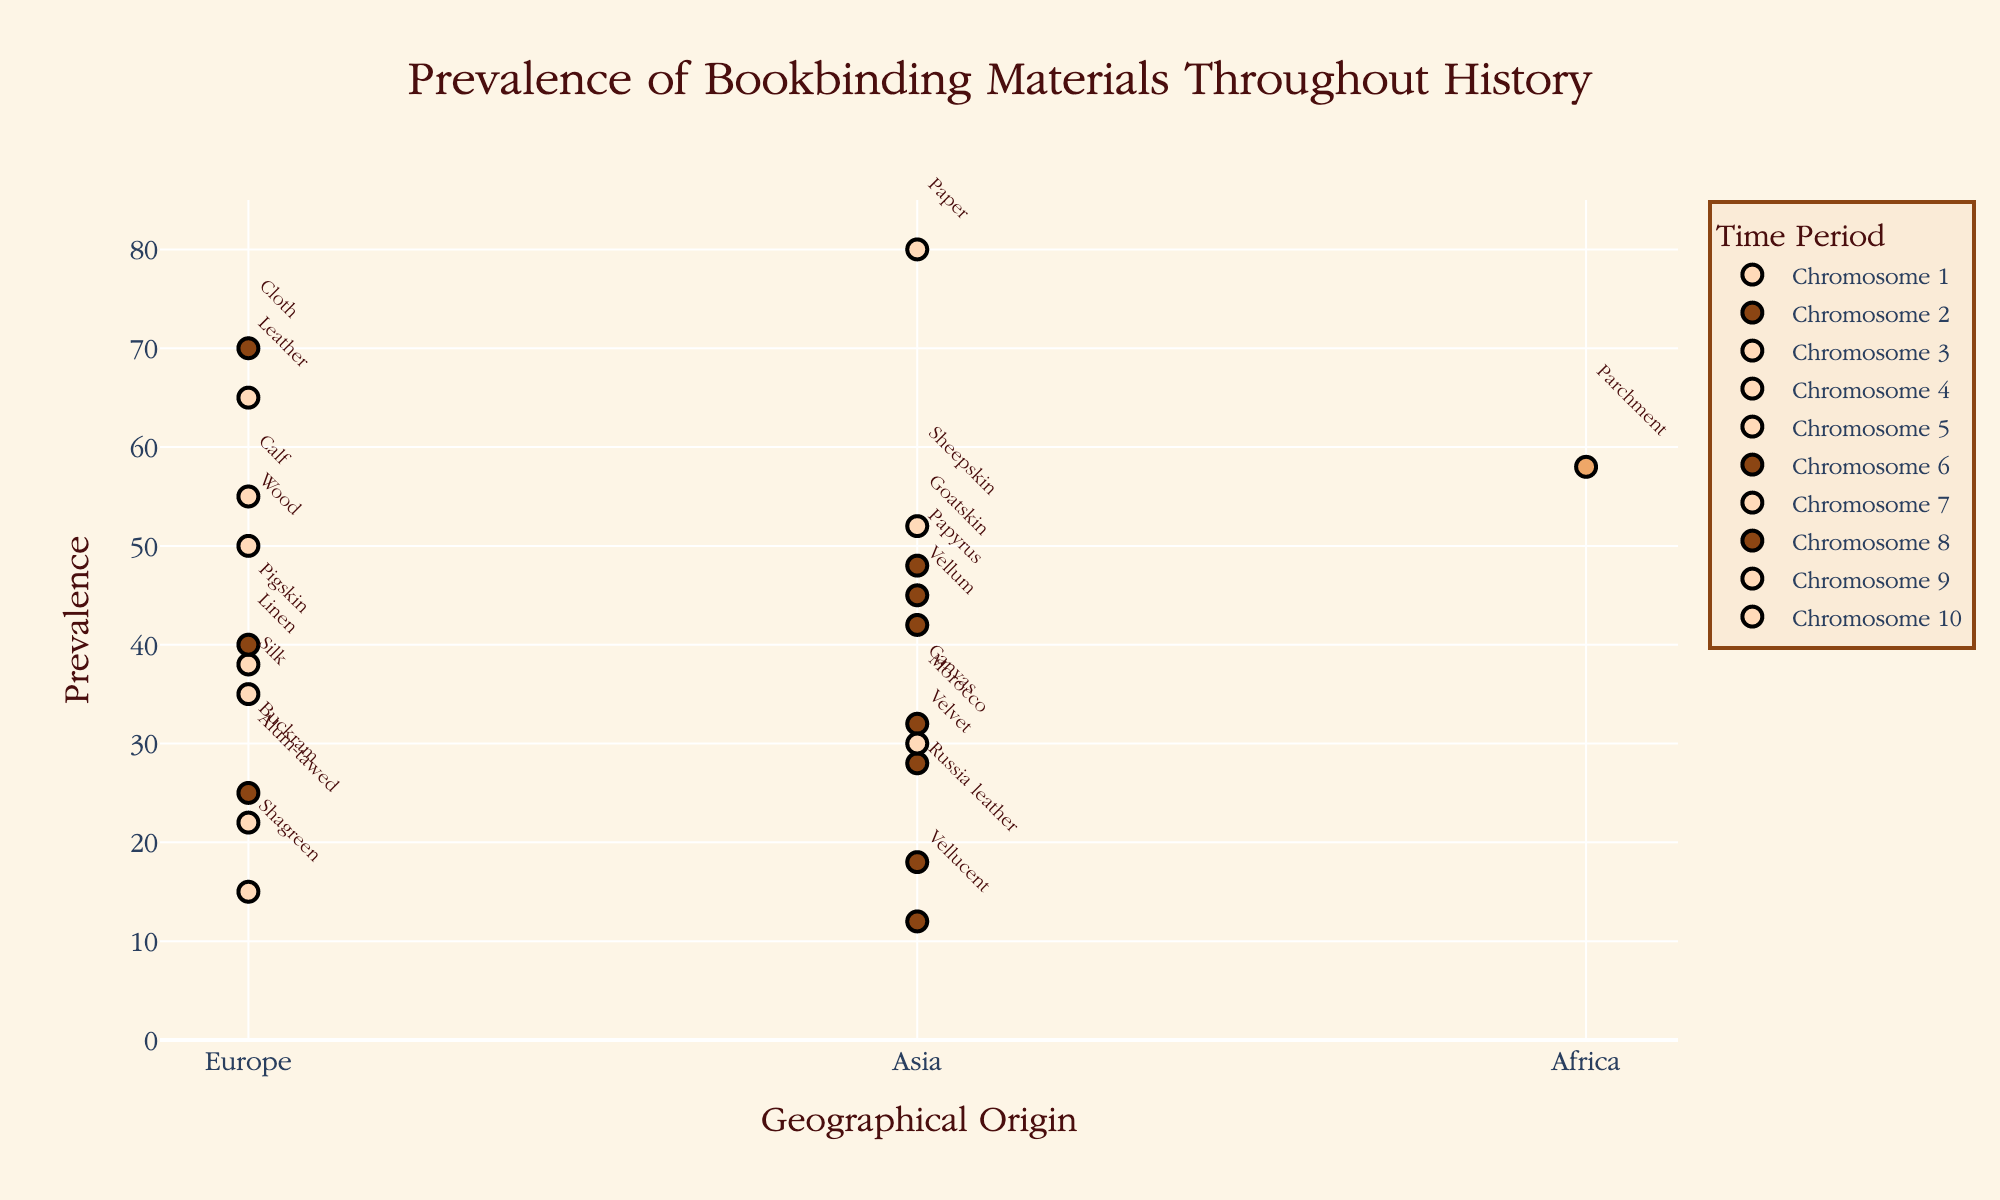What is the title of the plot? The title is located at the top of the plot and provides an overview of what the plot represents. In this case, it tells us about the subject matter of the plot.
Answer: Prevalence of Bookbinding Materials Throughout History What does the x-axis represent? The x-axis represents geographical origins with tick marks labeled as Europe, Asia, and Africa, indicating where the bookbinding materials were used the most.
Answer: Geographical Origin Which material has the highest prevalence value on the plot? By looking at the markers, the material with the highest y-coordinate signifies the highest prevalence.
Answer: Paper Which materials have a prevalence value above 50? Observing the y-axis and finding markers placed above the 50 line reveals the materials with a prevalence over this value.
Answer: Leather, Parchment, Cloth, Paper, Calf, Sheepskin Which geographical region has the most number of bookbinding materials with a prevalence above 40? First, identify geographical regions by examining the x-axis, then count the number of markers above the prevalence value of 40 for each region.
Answer: Europe Compare the prevalence of Leather and Vellum. Which one is more prevalent? Find the markers for Leather and Vellum and compare their y-coordinates to see which is higher.
Answer: Leather What is the total number of bookbinding materials listed in the plot? Count all the markers on the plot. Each marker represents a distinct bookbinding material.
Answer: 20 Which material has the lowest prevalence value, and what is its value? Locate the marker with the smallest y-coordinate; this marker represents the material with the lowest prevalence.
Answer: Vellucent, 12 Analyze the prevalence of Vellum in Asia, Europe, and Africa. Which region has the highest prevalence? Look for the positions marked as Asia, Europe, and Africa and find Vellum's prevalence in each. Compare the prevalence values to determine the highest.
Answer: Europe 